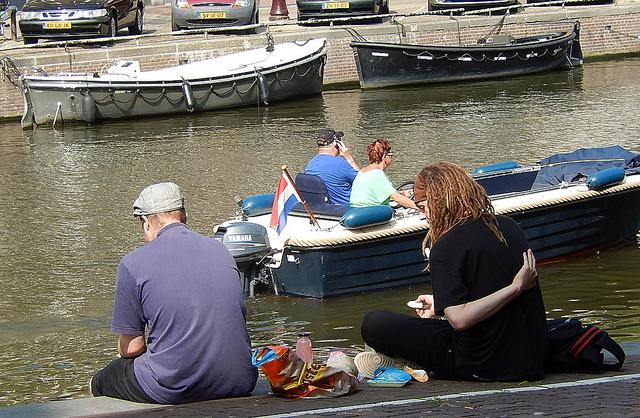A small vessel for travelling over water propelled by oars sails or an engine is? boat 